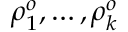<formula> <loc_0><loc_0><loc_500><loc_500>\rho _ { 1 } ^ { o } , \dots , \rho _ { k } ^ { o }</formula> 